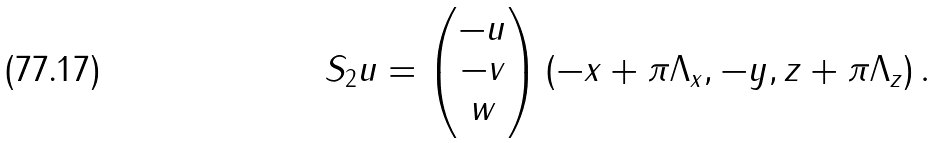<formula> <loc_0><loc_0><loc_500><loc_500>S _ { 2 } { u } = \begin{pmatrix} - u \\ - v \\ w \end{pmatrix} \left ( - x + \pi \Lambda _ { x } , - y , z + \pi \Lambda _ { z } \right ) .</formula> 